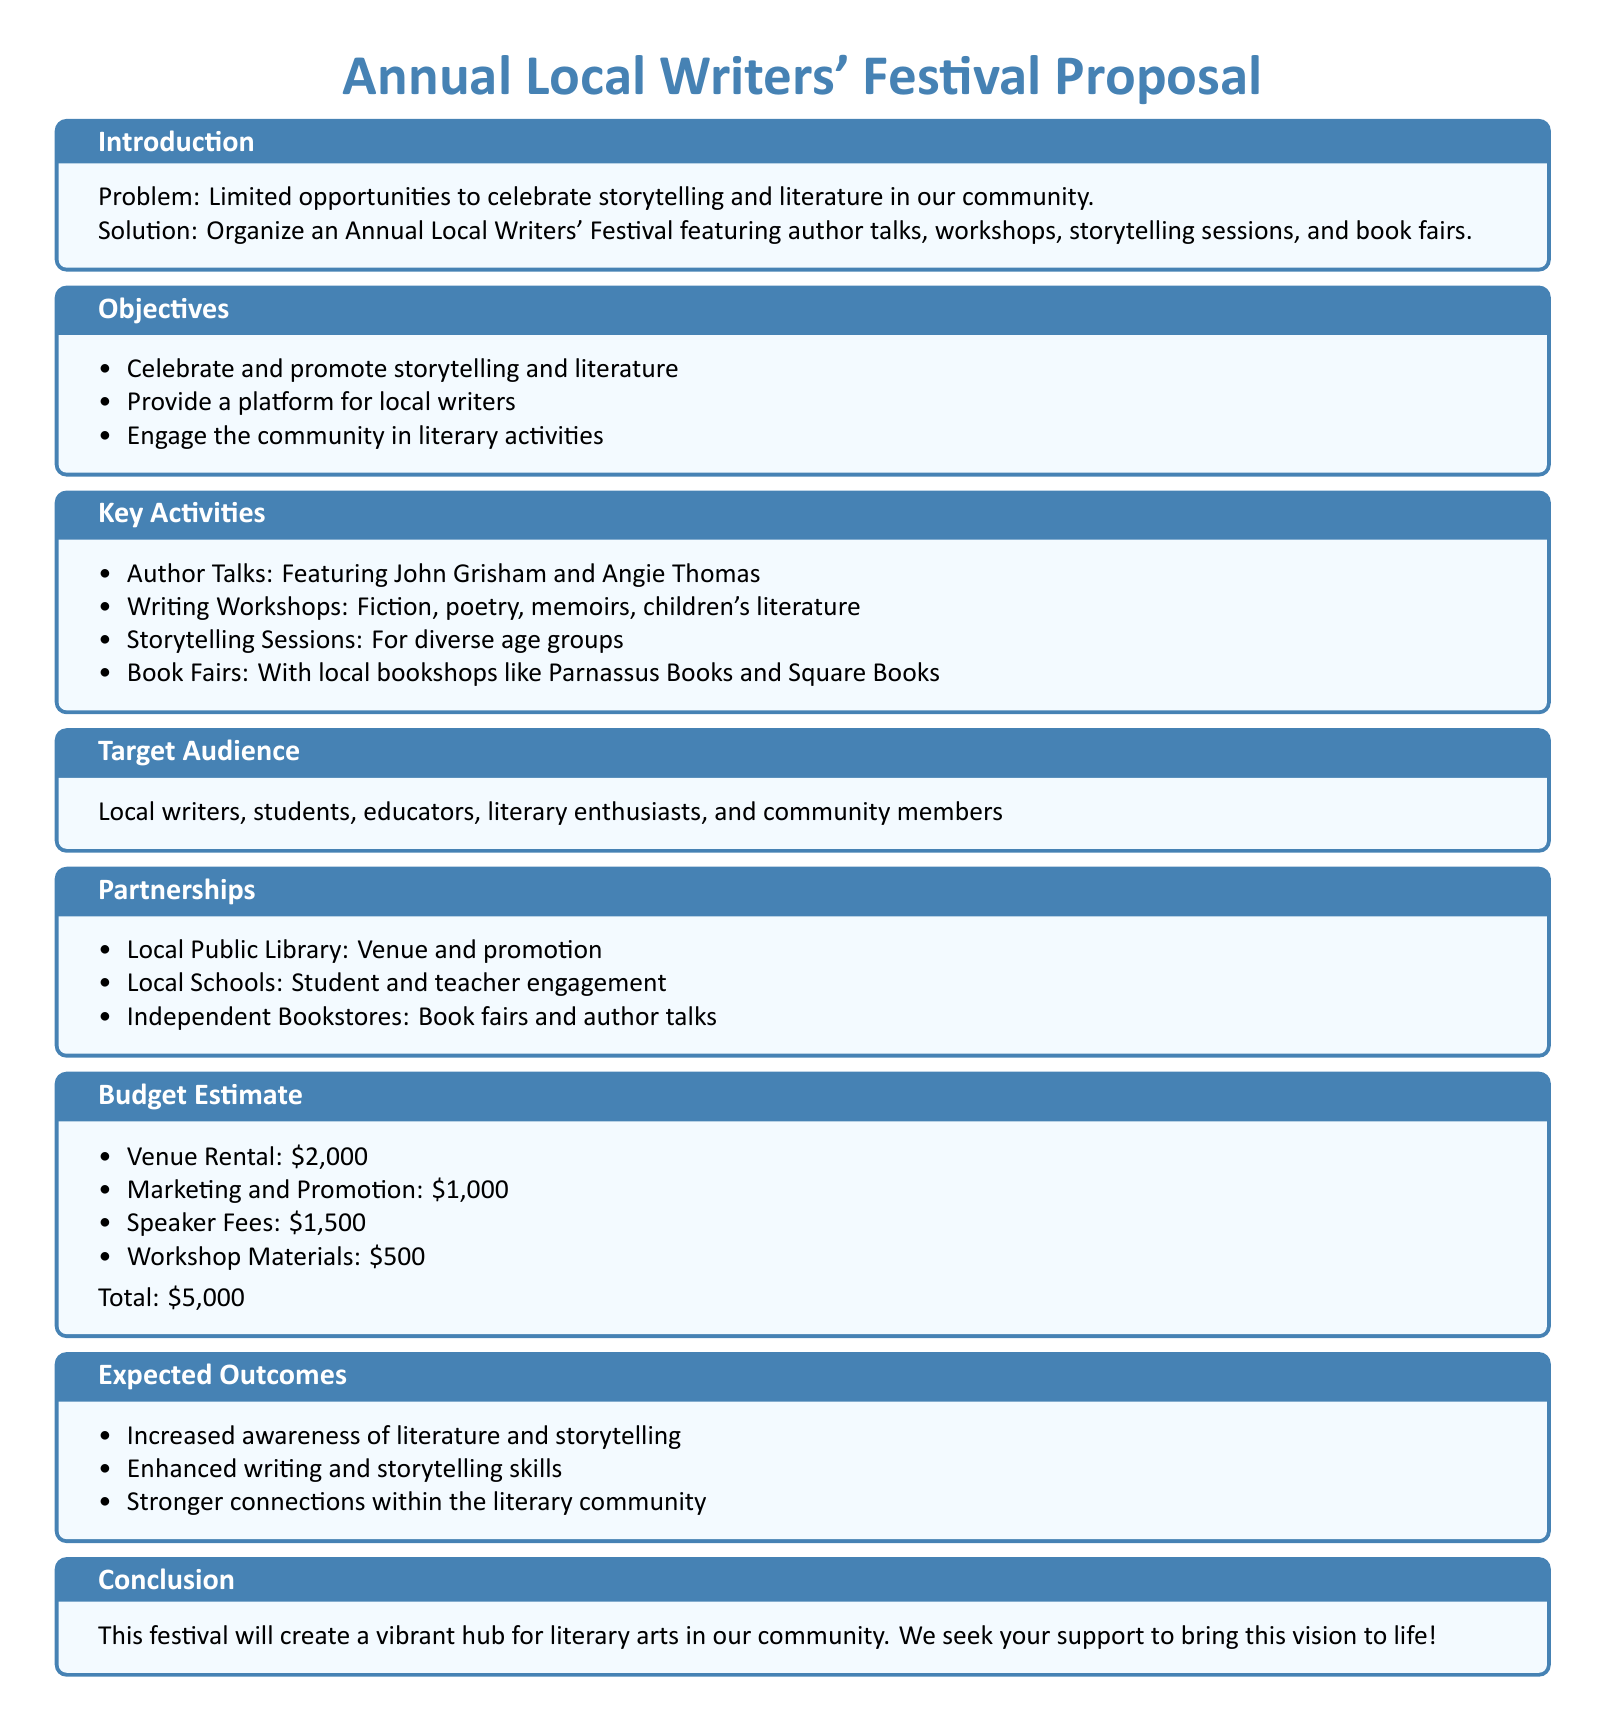What is the title of the proposal? The title of the proposal is stated at the beginning of the document.
Answer: Annual Local Writers' Festival Proposal What is the total budget estimate? The total budget estimate is calculated by summing all listed costs in the budget estimate section.
Answer: $5,000 Who are the featured authors in the festival? The featured authors are mentioned in the key activities section under author talks.
Answer: John Grisham and Angie Thomas What type of sessions will be included for different age groups? These sessions are categorized under key activities in the document.
Answer: Storytelling Sessions Which local partnership is mentioned for venue and promotion? The partnership is specified in the partnerships section of the document.
Answer: Local Public Library How many main objectives are listed in the proposal? The number of main objectives is counted in the objectives section.
Answer: Three What is one expected outcome of the festival? Expected outcomes are listed in a bullet point format in the document.
Answer: Increased awareness of literature and storytelling What type of workshops will be offered at the festival? The types of workshops are outlined in the key activities section of the proposal.
Answer: Fiction, poetry, memoirs, children's literature Who is the target audience for the festival? The target audience is stated in a specific section of the document.
Answer: Local writers, students, educators, literary enthusiasts, and community members 